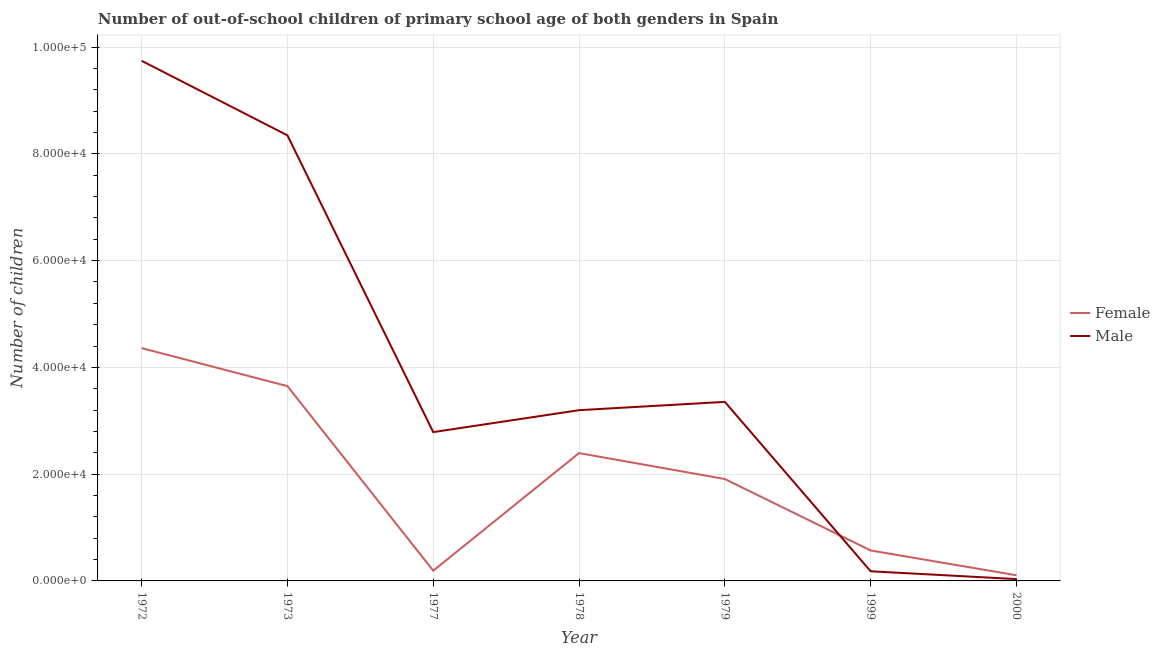How many different coloured lines are there?
Give a very brief answer. 2. Does the line corresponding to number of female out-of-school students intersect with the line corresponding to number of male out-of-school students?
Provide a succinct answer. Yes. Is the number of lines equal to the number of legend labels?
Offer a terse response. Yes. What is the number of male out-of-school students in 1977?
Provide a succinct answer. 2.79e+04. Across all years, what is the maximum number of male out-of-school students?
Your response must be concise. 9.74e+04. Across all years, what is the minimum number of female out-of-school students?
Offer a very short reply. 1061. In which year was the number of female out-of-school students maximum?
Offer a very short reply. 1972. In which year was the number of female out-of-school students minimum?
Offer a very short reply. 2000. What is the total number of male out-of-school students in the graph?
Your answer should be compact. 2.76e+05. What is the difference between the number of female out-of-school students in 1999 and that in 2000?
Offer a very short reply. 4644. What is the difference between the number of female out-of-school students in 1977 and the number of male out-of-school students in 2000?
Your response must be concise. 1576. What is the average number of female out-of-school students per year?
Provide a succinct answer. 1.88e+04. In the year 1979, what is the difference between the number of female out-of-school students and number of male out-of-school students?
Provide a succinct answer. -1.45e+04. What is the ratio of the number of male out-of-school students in 1973 to that in 1999?
Offer a very short reply. 46.22. Is the number of male out-of-school students in 1979 less than that in 2000?
Offer a very short reply. No. Is the difference between the number of male out-of-school students in 1972 and 1973 greater than the difference between the number of female out-of-school students in 1972 and 1973?
Offer a very short reply. Yes. What is the difference between the highest and the second highest number of female out-of-school students?
Your answer should be very brief. 7121. What is the difference between the highest and the lowest number of male out-of-school students?
Your response must be concise. 9.71e+04. Is the number of male out-of-school students strictly greater than the number of female out-of-school students over the years?
Give a very brief answer. No. Is the number of female out-of-school students strictly less than the number of male out-of-school students over the years?
Keep it short and to the point. No. What is the difference between two consecutive major ticks on the Y-axis?
Provide a succinct answer. 2.00e+04. Are the values on the major ticks of Y-axis written in scientific E-notation?
Your answer should be very brief. Yes. Where does the legend appear in the graph?
Offer a terse response. Center right. How many legend labels are there?
Your answer should be compact. 2. How are the legend labels stacked?
Give a very brief answer. Vertical. What is the title of the graph?
Offer a very short reply. Number of out-of-school children of primary school age of both genders in Spain. What is the label or title of the X-axis?
Ensure brevity in your answer.  Year. What is the label or title of the Y-axis?
Your answer should be compact. Number of children. What is the Number of children in Female in 1972?
Offer a very short reply. 4.36e+04. What is the Number of children of Male in 1972?
Provide a short and direct response. 9.74e+04. What is the Number of children of Female in 1973?
Offer a terse response. 3.65e+04. What is the Number of children of Male in 1973?
Provide a succinct answer. 8.35e+04. What is the Number of children of Female in 1977?
Ensure brevity in your answer.  1920. What is the Number of children in Male in 1977?
Make the answer very short. 2.79e+04. What is the Number of children in Female in 1978?
Offer a very short reply. 2.39e+04. What is the Number of children of Male in 1978?
Keep it short and to the point. 3.20e+04. What is the Number of children of Female in 1979?
Provide a short and direct response. 1.91e+04. What is the Number of children in Male in 1979?
Your response must be concise. 3.35e+04. What is the Number of children in Female in 1999?
Your answer should be very brief. 5705. What is the Number of children in Male in 1999?
Give a very brief answer. 1806. What is the Number of children of Female in 2000?
Provide a succinct answer. 1061. What is the Number of children of Male in 2000?
Offer a terse response. 344. Across all years, what is the maximum Number of children in Female?
Offer a very short reply. 4.36e+04. Across all years, what is the maximum Number of children of Male?
Provide a short and direct response. 9.74e+04. Across all years, what is the minimum Number of children in Female?
Keep it short and to the point. 1061. Across all years, what is the minimum Number of children of Male?
Your response must be concise. 344. What is the total Number of children in Female in the graph?
Your response must be concise. 1.32e+05. What is the total Number of children in Male in the graph?
Make the answer very short. 2.76e+05. What is the difference between the Number of children of Female in 1972 and that in 1973?
Your answer should be very brief. 7121. What is the difference between the Number of children in Male in 1972 and that in 1973?
Ensure brevity in your answer.  1.40e+04. What is the difference between the Number of children of Female in 1972 and that in 1977?
Provide a succinct answer. 4.17e+04. What is the difference between the Number of children of Male in 1972 and that in 1977?
Make the answer very short. 6.96e+04. What is the difference between the Number of children in Female in 1972 and that in 1978?
Offer a terse response. 1.97e+04. What is the difference between the Number of children of Male in 1972 and that in 1978?
Ensure brevity in your answer.  6.55e+04. What is the difference between the Number of children in Female in 1972 and that in 1979?
Offer a terse response. 2.45e+04. What is the difference between the Number of children of Male in 1972 and that in 1979?
Your answer should be very brief. 6.39e+04. What is the difference between the Number of children in Female in 1972 and that in 1999?
Your response must be concise. 3.79e+04. What is the difference between the Number of children of Male in 1972 and that in 1999?
Your answer should be very brief. 9.56e+04. What is the difference between the Number of children of Female in 1972 and that in 2000?
Ensure brevity in your answer.  4.26e+04. What is the difference between the Number of children in Male in 1972 and that in 2000?
Your answer should be very brief. 9.71e+04. What is the difference between the Number of children of Female in 1973 and that in 1977?
Your answer should be compact. 3.46e+04. What is the difference between the Number of children in Male in 1973 and that in 1977?
Your answer should be very brief. 5.56e+04. What is the difference between the Number of children of Female in 1973 and that in 1978?
Keep it short and to the point. 1.25e+04. What is the difference between the Number of children in Male in 1973 and that in 1978?
Your answer should be compact. 5.15e+04. What is the difference between the Number of children of Female in 1973 and that in 1979?
Offer a terse response. 1.74e+04. What is the difference between the Number of children in Male in 1973 and that in 1979?
Keep it short and to the point. 4.99e+04. What is the difference between the Number of children in Female in 1973 and that in 1999?
Make the answer very short. 3.08e+04. What is the difference between the Number of children of Male in 1973 and that in 1999?
Provide a succinct answer. 8.17e+04. What is the difference between the Number of children of Female in 1973 and that in 2000?
Your response must be concise. 3.54e+04. What is the difference between the Number of children of Male in 1973 and that in 2000?
Your answer should be very brief. 8.31e+04. What is the difference between the Number of children of Female in 1977 and that in 1978?
Provide a short and direct response. -2.20e+04. What is the difference between the Number of children in Male in 1977 and that in 1978?
Offer a very short reply. -4105. What is the difference between the Number of children of Female in 1977 and that in 1979?
Keep it short and to the point. -1.72e+04. What is the difference between the Number of children in Male in 1977 and that in 1979?
Your answer should be compact. -5663. What is the difference between the Number of children in Female in 1977 and that in 1999?
Offer a very short reply. -3785. What is the difference between the Number of children in Male in 1977 and that in 1999?
Offer a terse response. 2.61e+04. What is the difference between the Number of children of Female in 1977 and that in 2000?
Keep it short and to the point. 859. What is the difference between the Number of children of Male in 1977 and that in 2000?
Your answer should be compact. 2.75e+04. What is the difference between the Number of children of Female in 1978 and that in 1979?
Your answer should be compact. 4856. What is the difference between the Number of children in Male in 1978 and that in 1979?
Your answer should be very brief. -1558. What is the difference between the Number of children in Female in 1978 and that in 1999?
Provide a short and direct response. 1.82e+04. What is the difference between the Number of children in Male in 1978 and that in 1999?
Keep it short and to the point. 3.02e+04. What is the difference between the Number of children of Female in 1978 and that in 2000?
Make the answer very short. 2.29e+04. What is the difference between the Number of children in Male in 1978 and that in 2000?
Your response must be concise. 3.16e+04. What is the difference between the Number of children of Female in 1979 and that in 1999?
Offer a terse response. 1.34e+04. What is the difference between the Number of children in Male in 1979 and that in 1999?
Ensure brevity in your answer.  3.17e+04. What is the difference between the Number of children in Female in 1979 and that in 2000?
Make the answer very short. 1.80e+04. What is the difference between the Number of children in Male in 1979 and that in 2000?
Ensure brevity in your answer.  3.32e+04. What is the difference between the Number of children in Female in 1999 and that in 2000?
Make the answer very short. 4644. What is the difference between the Number of children of Male in 1999 and that in 2000?
Provide a succinct answer. 1462. What is the difference between the Number of children in Female in 1972 and the Number of children in Male in 1973?
Make the answer very short. -3.99e+04. What is the difference between the Number of children in Female in 1972 and the Number of children in Male in 1977?
Your answer should be compact. 1.57e+04. What is the difference between the Number of children of Female in 1972 and the Number of children of Male in 1978?
Ensure brevity in your answer.  1.16e+04. What is the difference between the Number of children of Female in 1972 and the Number of children of Male in 1979?
Make the answer very short. 1.01e+04. What is the difference between the Number of children in Female in 1972 and the Number of children in Male in 1999?
Your response must be concise. 4.18e+04. What is the difference between the Number of children in Female in 1972 and the Number of children in Male in 2000?
Keep it short and to the point. 4.33e+04. What is the difference between the Number of children of Female in 1973 and the Number of children of Male in 1977?
Your response must be concise. 8613. What is the difference between the Number of children of Female in 1973 and the Number of children of Male in 1978?
Ensure brevity in your answer.  4508. What is the difference between the Number of children of Female in 1973 and the Number of children of Male in 1979?
Your answer should be very brief. 2950. What is the difference between the Number of children of Female in 1973 and the Number of children of Male in 1999?
Offer a very short reply. 3.47e+04. What is the difference between the Number of children of Female in 1973 and the Number of children of Male in 2000?
Offer a terse response. 3.61e+04. What is the difference between the Number of children in Female in 1977 and the Number of children in Male in 1978?
Give a very brief answer. -3.01e+04. What is the difference between the Number of children in Female in 1977 and the Number of children in Male in 1979?
Give a very brief answer. -3.16e+04. What is the difference between the Number of children in Female in 1977 and the Number of children in Male in 1999?
Provide a short and direct response. 114. What is the difference between the Number of children in Female in 1977 and the Number of children in Male in 2000?
Give a very brief answer. 1576. What is the difference between the Number of children of Female in 1978 and the Number of children of Male in 1979?
Provide a short and direct response. -9595. What is the difference between the Number of children in Female in 1978 and the Number of children in Male in 1999?
Give a very brief answer. 2.21e+04. What is the difference between the Number of children in Female in 1978 and the Number of children in Male in 2000?
Make the answer very short. 2.36e+04. What is the difference between the Number of children in Female in 1979 and the Number of children in Male in 1999?
Your response must be concise. 1.73e+04. What is the difference between the Number of children in Female in 1979 and the Number of children in Male in 2000?
Make the answer very short. 1.87e+04. What is the difference between the Number of children of Female in 1999 and the Number of children of Male in 2000?
Offer a very short reply. 5361. What is the average Number of children of Female per year?
Offer a very short reply. 1.88e+04. What is the average Number of children in Male per year?
Give a very brief answer. 3.95e+04. In the year 1972, what is the difference between the Number of children in Female and Number of children in Male?
Offer a terse response. -5.38e+04. In the year 1973, what is the difference between the Number of children in Female and Number of children in Male?
Offer a terse response. -4.70e+04. In the year 1977, what is the difference between the Number of children in Female and Number of children in Male?
Your response must be concise. -2.60e+04. In the year 1978, what is the difference between the Number of children of Female and Number of children of Male?
Your answer should be very brief. -8037. In the year 1979, what is the difference between the Number of children of Female and Number of children of Male?
Offer a very short reply. -1.45e+04. In the year 1999, what is the difference between the Number of children of Female and Number of children of Male?
Offer a terse response. 3899. In the year 2000, what is the difference between the Number of children of Female and Number of children of Male?
Your response must be concise. 717. What is the ratio of the Number of children in Female in 1972 to that in 1973?
Offer a very short reply. 1.2. What is the ratio of the Number of children in Male in 1972 to that in 1973?
Offer a very short reply. 1.17. What is the ratio of the Number of children of Female in 1972 to that in 1977?
Offer a terse response. 22.71. What is the ratio of the Number of children in Male in 1972 to that in 1977?
Offer a very short reply. 3.5. What is the ratio of the Number of children of Female in 1972 to that in 1978?
Ensure brevity in your answer.  1.82. What is the ratio of the Number of children of Male in 1972 to that in 1978?
Your response must be concise. 3.05. What is the ratio of the Number of children of Female in 1972 to that in 1979?
Your answer should be compact. 2.28. What is the ratio of the Number of children in Male in 1972 to that in 1979?
Give a very brief answer. 2.9. What is the ratio of the Number of children in Female in 1972 to that in 1999?
Give a very brief answer. 7.64. What is the ratio of the Number of children in Male in 1972 to that in 1999?
Keep it short and to the point. 53.95. What is the ratio of the Number of children of Female in 1972 to that in 2000?
Your answer should be very brief. 41.1. What is the ratio of the Number of children of Male in 1972 to that in 2000?
Provide a succinct answer. 283.24. What is the ratio of the Number of children of Female in 1973 to that in 1977?
Keep it short and to the point. 19.01. What is the ratio of the Number of children of Male in 1973 to that in 1977?
Ensure brevity in your answer.  2.99. What is the ratio of the Number of children of Female in 1973 to that in 1978?
Offer a very short reply. 1.52. What is the ratio of the Number of children in Male in 1973 to that in 1978?
Give a very brief answer. 2.61. What is the ratio of the Number of children of Female in 1973 to that in 1979?
Offer a very short reply. 1.91. What is the ratio of the Number of children in Male in 1973 to that in 1979?
Your answer should be very brief. 2.49. What is the ratio of the Number of children of Female in 1973 to that in 1999?
Your answer should be very brief. 6.4. What is the ratio of the Number of children of Male in 1973 to that in 1999?
Keep it short and to the point. 46.22. What is the ratio of the Number of children in Female in 1973 to that in 2000?
Offer a very short reply. 34.39. What is the ratio of the Number of children in Male in 1973 to that in 2000?
Make the answer very short. 242.65. What is the ratio of the Number of children of Female in 1977 to that in 1978?
Your response must be concise. 0.08. What is the ratio of the Number of children of Male in 1977 to that in 1978?
Give a very brief answer. 0.87. What is the ratio of the Number of children in Female in 1977 to that in 1979?
Provide a succinct answer. 0.1. What is the ratio of the Number of children of Male in 1977 to that in 1979?
Your answer should be very brief. 0.83. What is the ratio of the Number of children in Female in 1977 to that in 1999?
Keep it short and to the point. 0.34. What is the ratio of the Number of children of Male in 1977 to that in 1999?
Keep it short and to the point. 15.44. What is the ratio of the Number of children of Female in 1977 to that in 2000?
Offer a very short reply. 1.81. What is the ratio of the Number of children of Male in 1977 to that in 2000?
Provide a short and direct response. 81.04. What is the ratio of the Number of children of Female in 1978 to that in 1979?
Provide a succinct answer. 1.25. What is the ratio of the Number of children in Male in 1978 to that in 1979?
Offer a very short reply. 0.95. What is the ratio of the Number of children in Female in 1978 to that in 1999?
Offer a very short reply. 4.2. What is the ratio of the Number of children in Male in 1978 to that in 1999?
Offer a very short reply. 17.71. What is the ratio of the Number of children of Female in 1978 to that in 2000?
Your answer should be compact. 22.57. What is the ratio of the Number of children in Male in 1978 to that in 2000?
Give a very brief answer. 92.97. What is the ratio of the Number of children of Female in 1979 to that in 1999?
Your response must be concise. 3.35. What is the ratio of the Number of children in Male in 1979 to that in 1999?
Ensure brevity in your answer.  18.57. What is the ratio of the Number of children in Female in 1979 to that in 2000?
Make the answer very short. 17.99. What is the ratio of the Number of children of Male in 1979 to that in 2000?
Provide a short and direct response. 97.5. What is the ratio of the Number of children of Female in 1999 to that in 2000?
Give a very brief answer. 5.38. What is the ratio of the Number of children of Male in 1999 to that in 2000?
Give a very brief answer. 5.25. What is the difference between the highest and the second highest Number of children of Female?
Your answer should be compact. 7121. What is the difference between the highest and the second highest Number of children in Male?
Provide a short and direct response. 1.40e+04. What is the difference between the highest and the lowest Number of children of Female?
Your answer should be compact. 4.26e+04. What is the difference between the highest and the lowest Number of children in Male?
Your answer should be compact. 9.71e+04. 